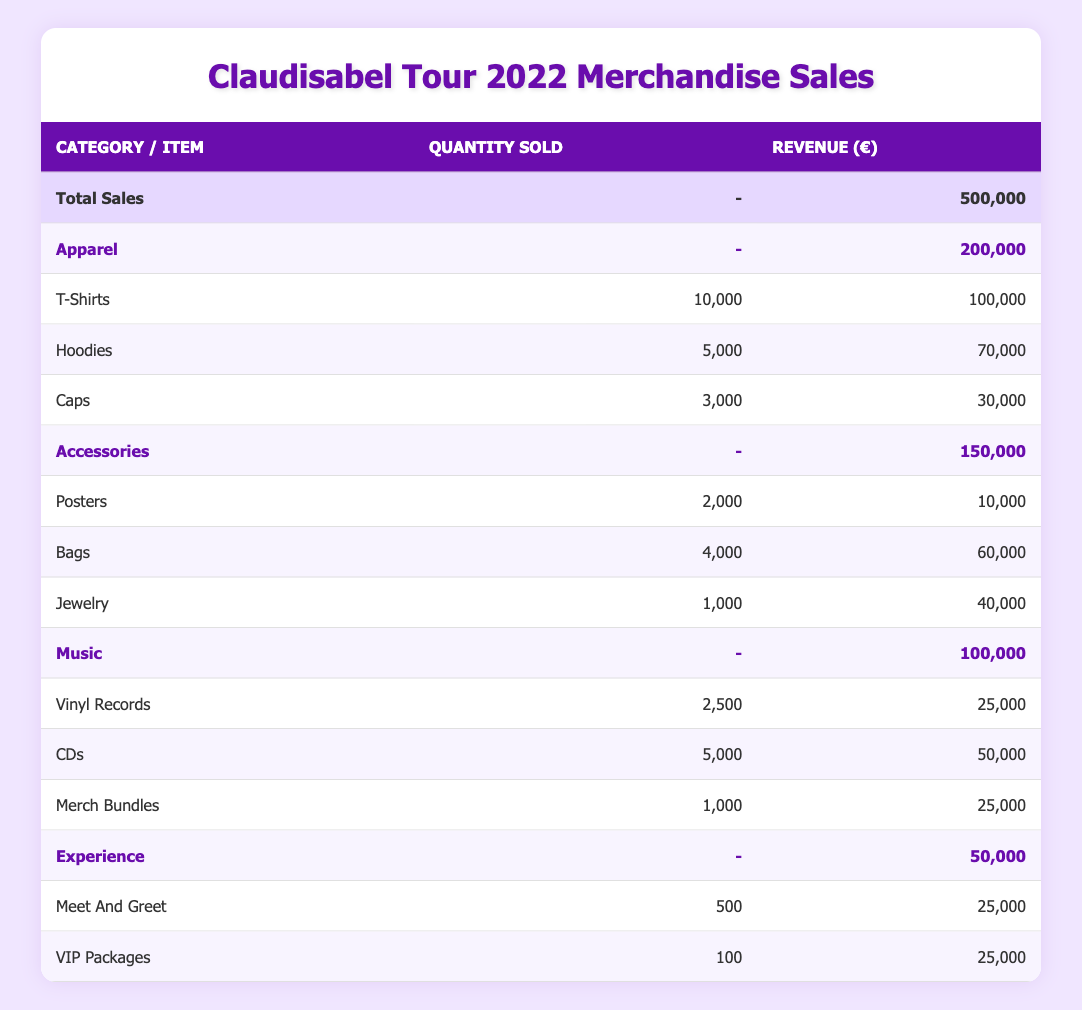What is the total revenue generated from merchandise sales during Claudisabel's tour in 2022? The total revenue is explicitly stated in the table's total sales row, which indicates revenue of 500,000 euros.
Answer: 500,000 euros How many T-Shirts were sold during the tour? The quantity sold for T-Shirts is listed directly in the table, showing 10,000 T-Shirts were sold.
Answer: 10,000 What category of merchandise generated the highest sales revenue? By comparing the revenue figures provided for each category (Apparel: 200,000; Accessories: 150,000; Music: 100,000; Experience: 50,000), it's clear that Apparel has the highest revenue of 200,000 euros.
Answer: Apparel How many total items were sold in the Accessories category? To find the total, I add the sold quantities of each item within the Accessories category: Posters (2,000) + Bags (4,000) + Jewelry (1,000) = 7,000 items sold.
Answer: 7,000 Did the revenue from VIP Packages exceed the revenue from Posters? The revenue from VIP Packages and Posters can be compared: VIP Packages generated 25,000 euros, while Posters generated 10,000 euros. Since 25,000 is greater than 10,000, the revenue from VIP Packages does exceed that of Posters.
Answer: Yes What is the average revenue generated by each type of item sold in the Music category? The Music category includes three items with revenues: Vinyl Records (25,000), CDs (50,000), and Merch Bundles (25,000). The total revenue is 100,000 euros, and there are 3 items, leading to an average of 100,000 / 3 = approximately 33,333 euros.
Answer: Approximately 33,333 euros If the sales of Bags were removed from the Accessories category, what would the new total revenue for Accessories be? The original total for Accessories is 150,000 euros. The revenue from Bags is 60,000 euros. Therefore, the revised total would be 150,000 - 60,000 = 90,000 euros.
Answer: 90,000 euros Which merchandise category had the least total revenue? By reviewing the total revenue for each category, it's evident that the Experience category at 50,000 euros is the lowest.
Answer: Experience How much revenue was generated by Meet and Greet compared to the revenue from Jewelry? The item Meet and Greet generated 25,000 euros and Jewelry generated 40,000 euros. Comparing these two values shows that Jewelry generated more revenue.
Answer: Jewelry generated more revenue 